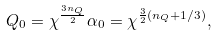<formula> <loc_0><loc_0><loc_500><loc_500>Q _ { 0 } = \chi ^ { \frac { 3 n _ { Q } } { 2 } } \alpha _ { 0 } = \chi ^ { \frac { 3 } { 2 } ( n _ { Q } + 1 / 3 ) } ,</formula> 